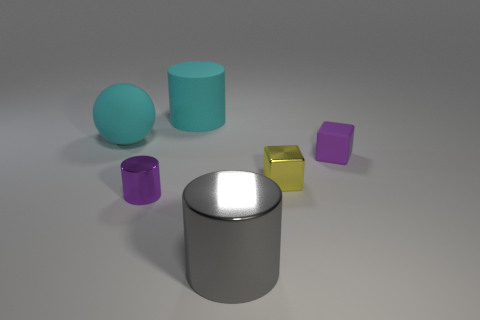Subtract all small metal cylinders. How many cylinders are left? 2 Add 3 large yellow spheres. How many objects exist? 9 Subtract all cyan cylinders. How many cylinders are left? 2 Subtract all blocks. How many objects are left? 4 Subtract 3 cylinders. How many cylinders are left? 0 Subtract all brown cylinders. How many brown blocks are left? 0 Subtract all red blocks. Subtract all yellow spheres. How many blocks are left? 2 Subtract all small brown metallic spheres. Subtract all cyan matte cylinders. How many objects are left? 5 Add 6 big gray shiny things. How many big gray shiny things are left? 7 Add 3 small red cylinders. How many small red cylinders exist? 3 